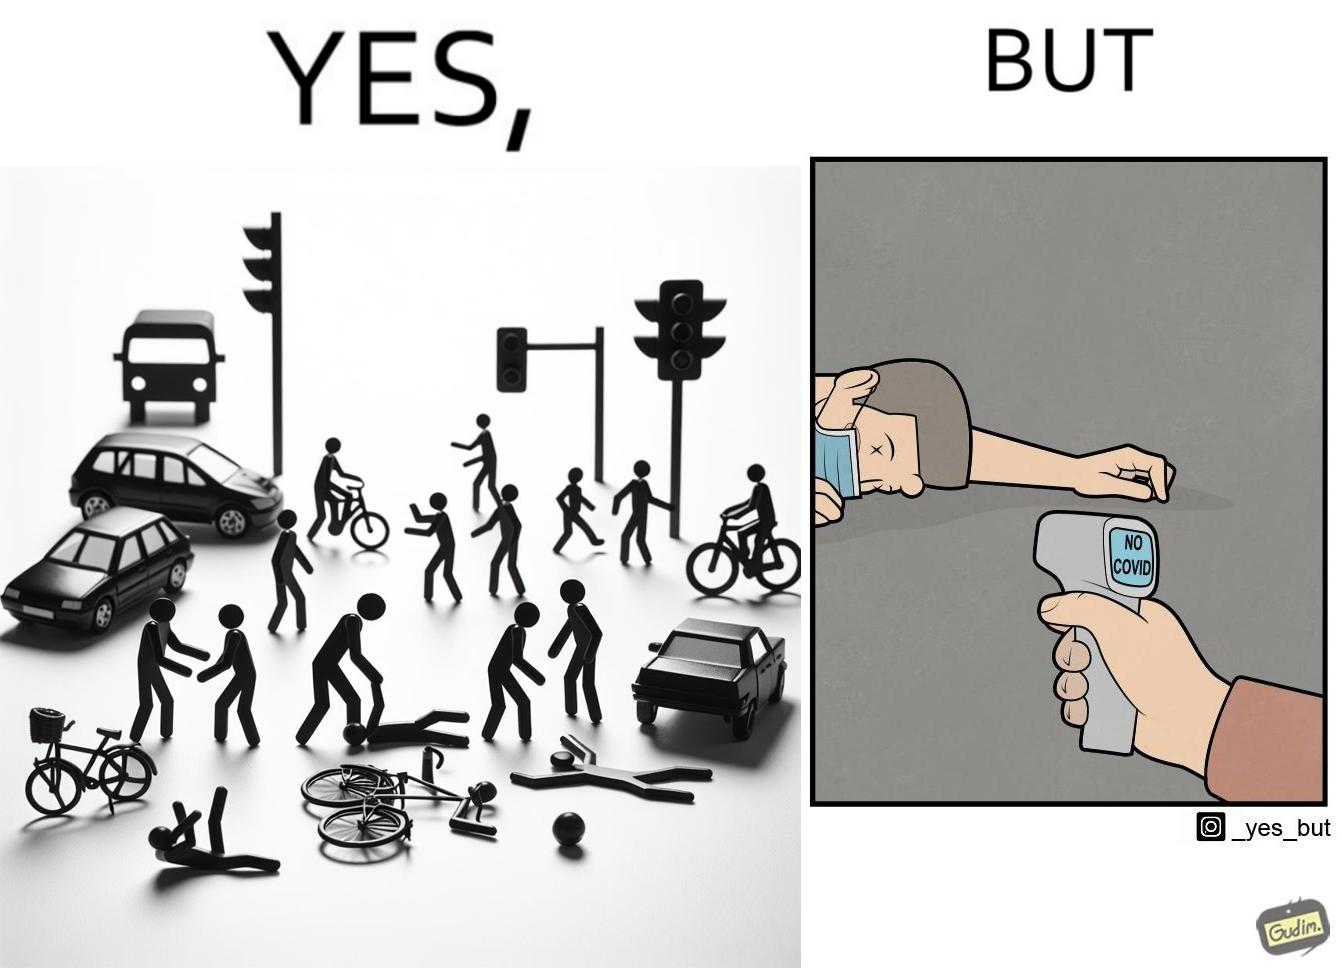Describe what you see in this image. the irony in the image comes from people trying to avoid covid, where a injured person is scanned for covid before they get help. 